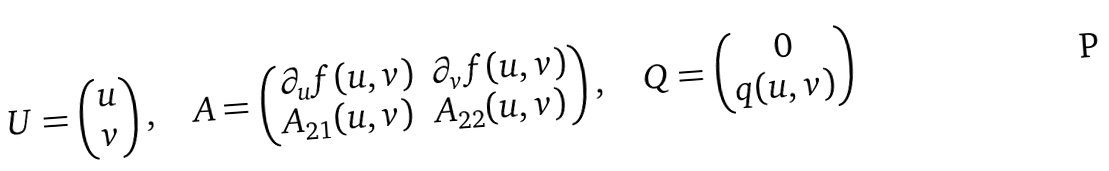Convert formula to latex. <formula><loc_0><loc_0><loc_500><loc_500>U = \begin{pmatrix} u \\ v \end{pmatrix} , \quad A = \begin{pmatrix} \partial _ { u } f ( u , v ) & \partial _ { v } f ( u , v ) \\ A _ { 2 1 } ( u , v ) & A _ { 2 2 } ( u , v ) \end{pmatrix} , \quad Q = \begin{pmatrix} 0 \\ q ( u , v ) \end{pmatrix}</formula> 